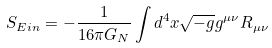<formula> <loc_0><loc_0><loc_500><loc_500>S _ { E i n } = - \frac { 1 } { 1 6 \pi G _ { N } } \int d ^ { 4 } x \sqrt { - g } g ^ { \mu \nu } R _ { \mu \nu }</formula> 